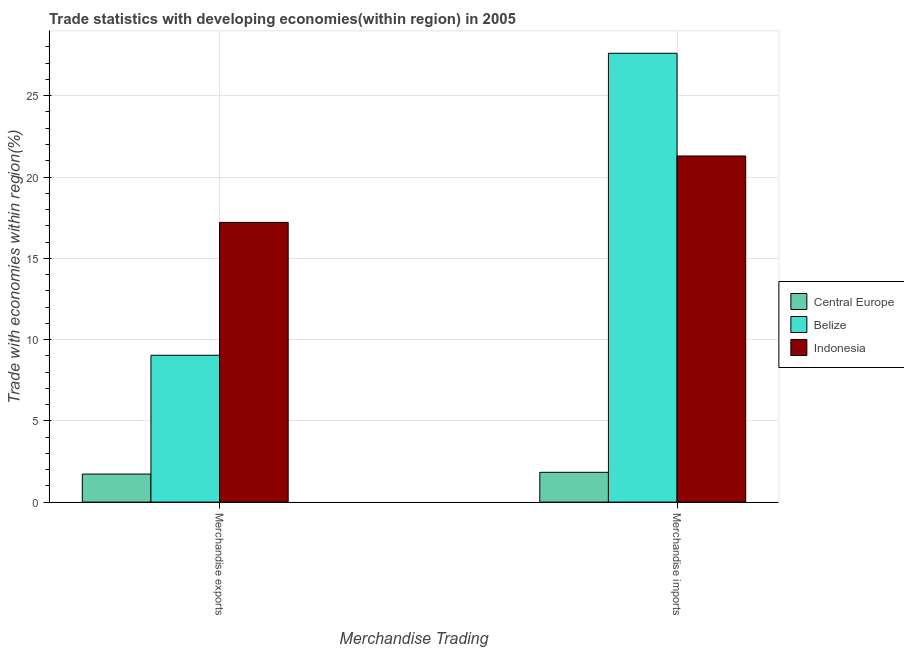How many different coloured bars are there?
Offer a very short reply. 3. How many groups of bars are there?
Keep it short and to the point. 2. What is the merchandise exports in Central Europe?
Your answer should be very brief. 1.73. Across all countries, what is the maximum merchandise imports?
Keep it short and to the point. 27.61. Across all countries, what is the minimum merchandise imports?
Provide a succinct answer. 1.83. In which country was the merchandise exports maximum?
Your response must be concise. Indonesia. In which country was the merchandise exports minimum?
Ensure brevity in your answer.  Central Europe. What is the total merchandise imports in the graph?
Offer a terse response. 50.74. What is the difference between the merchandise imports in Belize and that in Indonesia?
Give a very brief answer. 6.32. What is the difference between the merchandise imports in Indonesia and the merchandise exports in Belize?
Your response must be concise. 12.26. What is the average merchandise imports per country?
Your answer should be compact. 16.91. What is the difference between the merchandise exports and merchandise imports in Indonesia?
Provide a succinct answer. -4.09. What is the ratio of the merchandise exports in Central Europe to that in Indonesia?
Keep it short and to the point. 0.1. What does the 2nd bar from the right in Merchandise imports represents?
Your response must be concise. Belize. How many bars are there?
Offer a very short reply. 6. Are all the bars in the graph horizontal?
Your response must be concise. No. What is the difference between two consecutive major ticks on the Y-axis?
Make the answer very short. 5. Does the graph contain any zero values?
Keep it short and to the point. No. Where does the legend appear in the graph?
Give a very brief answer. Center right. What is the title of the graph?
Make the answer very short. Trade statistics with developing economies(within region) in 2005. What is the label or title of the X-axis?
Make the answer very short. Merchandise Trading. What is the label or title of the Y-axis?
Your response must be concise. Trade with economies within region(%). What is the Trade with economies within region(%) in Central Europe in Merchandise exports?
Keep it short and to the point. 1.73. What is the Trade with economies within region(%) of Belize in Merchandise exports?
Offer a very short reply. 9.03. What is the Trade with economies within region(%) in Indonesia in Merchandise exports?
Your answer should be very brief. 17.21. What is the Trade with economies within region(%) in Central Europe in Merchandise imports?
Offer a terse response. 1.83. What is the Trade with economies within region(%) of Belize in Merchandise imports?
Provide a succinct answer. 27.61. What is the Trade with economies within region(%) of Indonesia in Merchandise imports?
Provide a succinct answer. 21.29. Across all Merchandise Trading, what is the maximum Trade with economies within region(%) of Central Europe?
Give a very brief answer. 1.83. Across all Merchandise Trading, what is the maximum Trade with economies within region(%) in Belize?
Make the answer very short. 27.61. Across all Merchandise Trading, what is the maximum Trade with economies within region(%) in Indonesia?
Your response must be concise. 21.29. Across all Merchandise Trading, what is the minimum Trade with economies within region(%) in Central Europe?
Provide a short and direct response. 1.73. Across all Merchandise Trading, what is the minimum Trade with economies within region(%) in Belize?
Provide a succinct answer. 9.03. Across all Merchandise Trading, what is the minimum Trade with economies within region(%) in Indonesia?
Your answer should be compact. 17.21. What is the total Trade with economies within region(%) in Central Europe in the graph?
Offer a terse response. 3.56. What is the total Trade with economies within region(%) in Belize in the graph?
Offer a very short reply. 36.65. What is the total Trade with economies within region(%) of Indonesia in the graph?
Your answer should be very brief. 38.5. What is the difference between the Trade with economies within region(%) of Central Europe in Merchandise exports and that in Merchandise imports?
Make the answer very short. -0.11. What is the difference between the Trade with economies within region(%) of Belize in Merchandise exports and that in Merchandise imports?
Your answer should be very brief. -18.58. What is the difference between the Trade with economies within region(%) of Indonesia in Merchandise exports and that in Merchandise imports?
Your answer should be compact. -4.09. What is the difference between the Trade with economies within region(%) of Central Europe in Merchandise exports and the Trade with economies within region(%) of Belize in Merchandise imports?
Your response must be concise. -25.89. What is the difference between the Trade with economies within region(%) of Central Europe in Merchandise exports and the Trade with economies within region(%) of Indonesia in Merchandise imports?
Provide a succinct answer. -19.57. What is the difference between the Trade with economies within region(%) in Belize in Merchandise exports and the Trade with economies within region(%) in Indonesia in Merchandise imports?
Your answer should be very brief. -12.26. What is the average Trade with economies within region(%) of Central Europe per Merchandise Trading?
Offer a terse response. 1.78. What is the average Trade with economies within region(%) in Belize per Merchandise Trading?
Provide a succinct answer. 18.32. What is the average Trade with economies within region(%) in Indonesia per Merchandise Trading?
Your answer should be very brief. 19.25. What is the difference between the Trade with economies within region(%) in Central Europe and Trade with economies within region(%) in Belize in Merchandise exports?
Make the answer very short. -7.31. What is the difference between the Trade with economies within region(%) of Central Europe and Trade with economies within region(%) of Indonesia in Merchandise exports?
Make the answer very short. -15.48. What is the difference between the Trade with economies within region(%) of Belize and Trade with economies within region(%) of Indonesia in Merchandise exports?
Provide a short and direct response. -8.17. What is the difference between the Trade with economies within region(%) of Central Europe and Trade with economies within region(%) of Belize in Merchandise imports?
Your answer should be very brief. -25.78. What is the difference between the Trade with economies within region(%) of Central Europe and Trade with economies within region(%) of Indonesia in Merchandise imports?
Offer a terse response. -19.46. What is the difference between the Trade with economies within region(%) in Belize and Trade with economies within region(%) in Indonesia in Merchandise imports?
Give a very brief answer. 6.32. What is the ratio of the Trade with economies within region(%) in Central Europe in Merchandise exports to that in Merchandise imports?
Your response must be concise. 0.94. What is the ratio of the Trade with economies within region(%) in Belize in Merchandise exports to that in Merchandise imports?
Your answer should be compact. 0.33. What is the ratio of the Trade with economies within region(%) of Indonesia in Merchandise exports to that in Merchandise imports?
Offer a very short reply. 0.81. What is the difference between the highest and the second highest Trade with economies within region(%) of Central Europe?
Offer a very short reply. 0.11. What is the difference between the highest and the second highest Trade with economies within region(%) in Belize?
Provide a succinct answer. 18.58. What is the difference between the highest and the second highest Trade with economies within region(%) in Indonesia?
Provide a short and direct response. 4.09. What is the difference between the highest and the lowest Trade with economies within region(%) of Central Europe?
Provide a short and direct response. 0.11. What is the difference between the highest and the lowest Trade with economies within region(%) in Belize?
Your answer should be very brief. 18.58. What is the difference between the highest and the lowest Trade with economies within region(%) of Indonesia?
Offer a terse response. 4.09. 